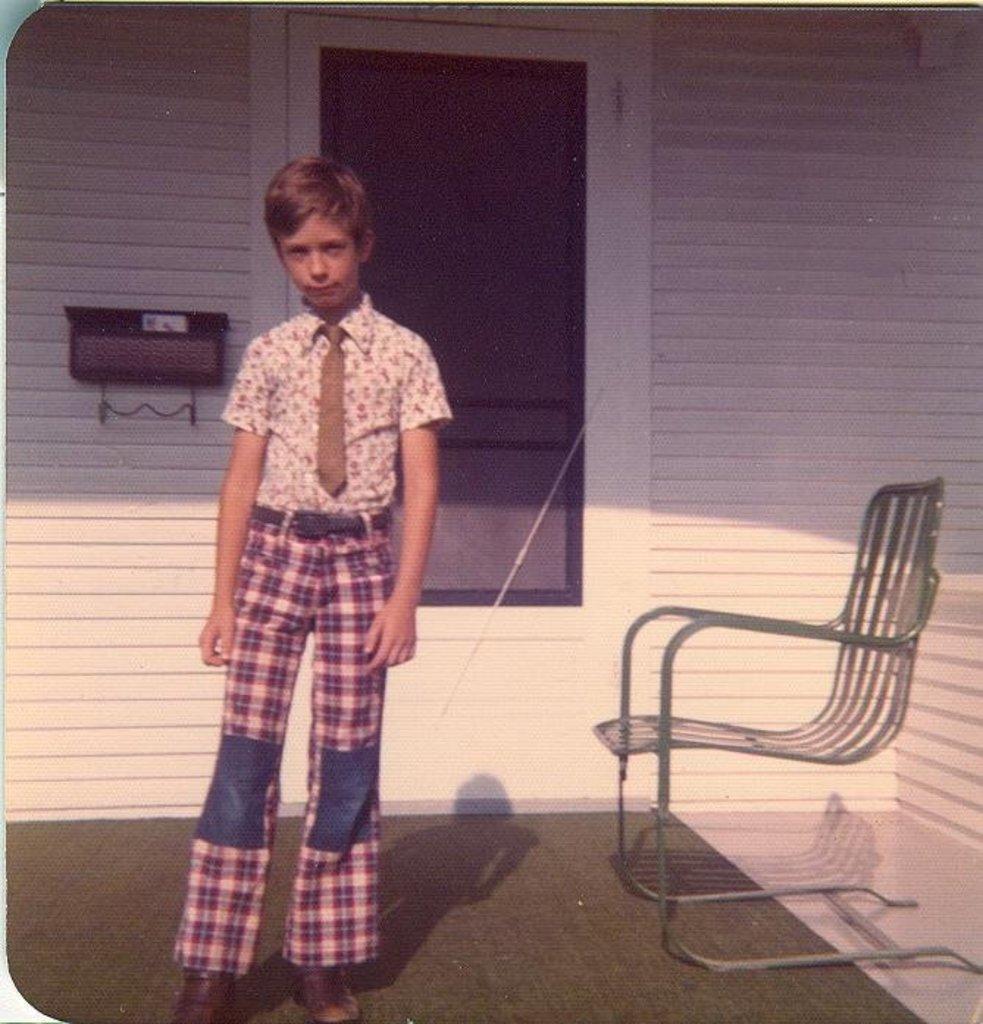Can you describe this image briefly? In this image there is a boy standing on the carpet, and at the background there is a chair, door, wall. 